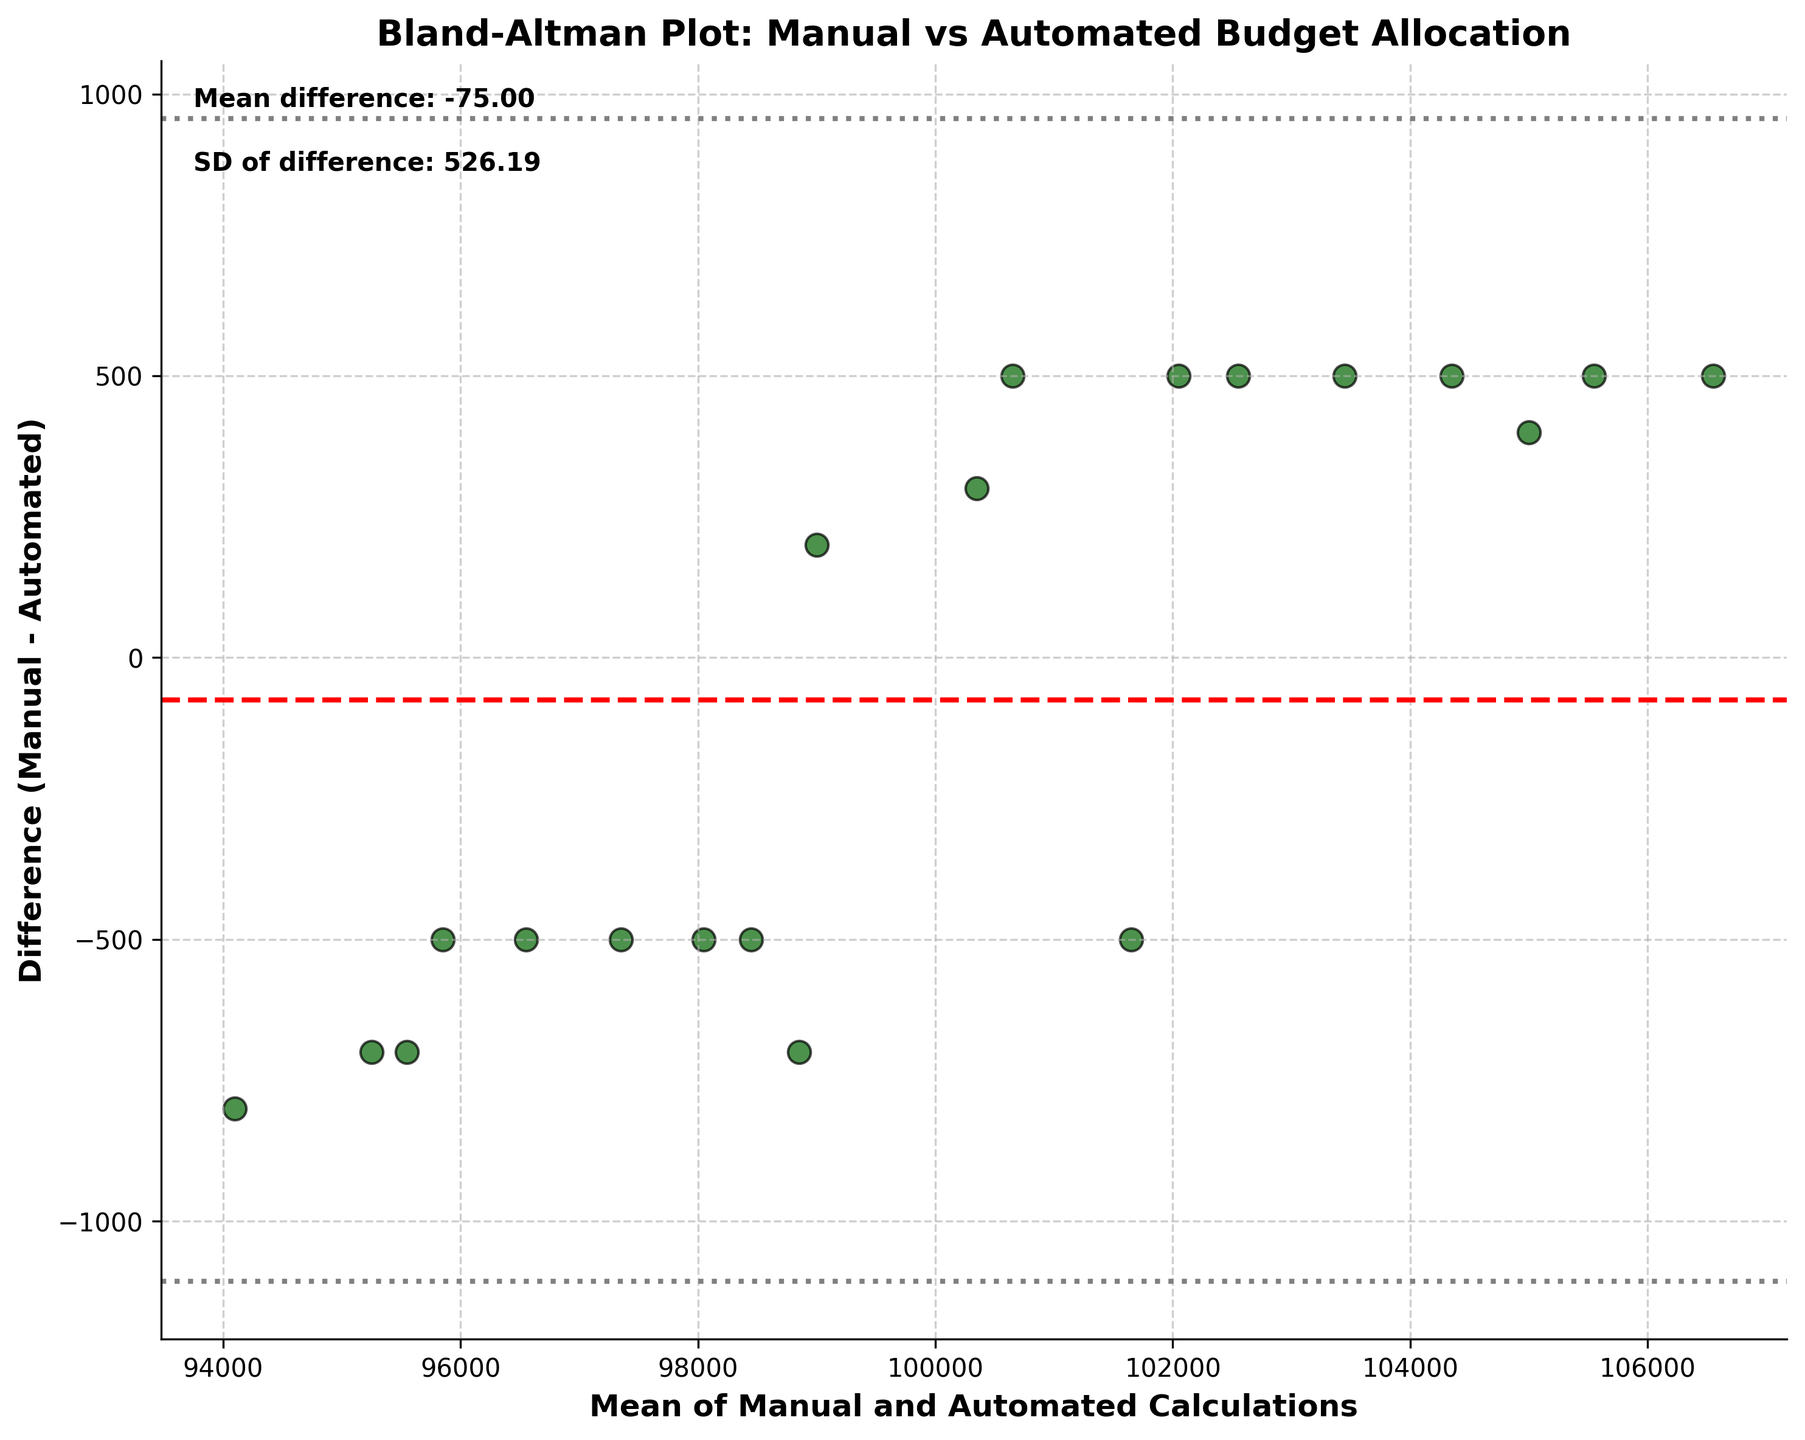What is the title of the plot? The title of the plot is located at the top. We can derive it by reading the text there.
Answer: Bland-Altman Plot: Manual vs Automated Budget Allocation How many data points are plotted on the graph? Each point on the graph represents a pair of measurements, and we can count these points to get the number.
Answer: 20 What are the labels of the X and Y axes? The labels of the axes are found directly on the axes themselves, specifying what each axis represents.
Answer: X: Mean of Manual and Automated Calculations, Y: Difference (Manual - Automated) Which color represents the data points? The color of the data points can be determined by visually inspecting the scatter plot.
Answer: Dark green What do the dashed and dotted horizontal lines represent? Dashed and dotted lines typically indicate statistical measures. The dashed line shows the mean difference, and the dotted lines show the limits of agreement, which are ±1.96 times the standard deviation from the mean difference.
Answer: Dashed: Mean difference, Dotted: Limits of agreement What is the mean difference according to the plot? The mean difference is indicated by the dashed red horizontal line. The value can also be found in the text annotation on the plot.
Answer: -175 Are any data points beyond the limit of agreement lines? By visually inspecting the plot, we can see if any data points lie outside the limits set by the dotted lines.
Answer: No What is the standard deviation of the differences? The standard deviation is provided in the text annotation on the plot, generally in conjunction with the mean difference.
Answer: 500 What is the overall trend of the differences in relation to the mean values? The trend can be assessed by observing the scatter of the data points in relation to the mean values on the X-axis. If the data points are mostly scattering evenly without a trend upward or downward, we say there's no apparent trend.
Answer: No apparent trend Which has greater variability, the mean difference or the individual differences? This is determined by comparing the mean difference value and the standard deviation of the differences. In this case, understanding that the variability is greater if the standard deviation is higher than the absolute mean difference.
Answer: Individual differences 